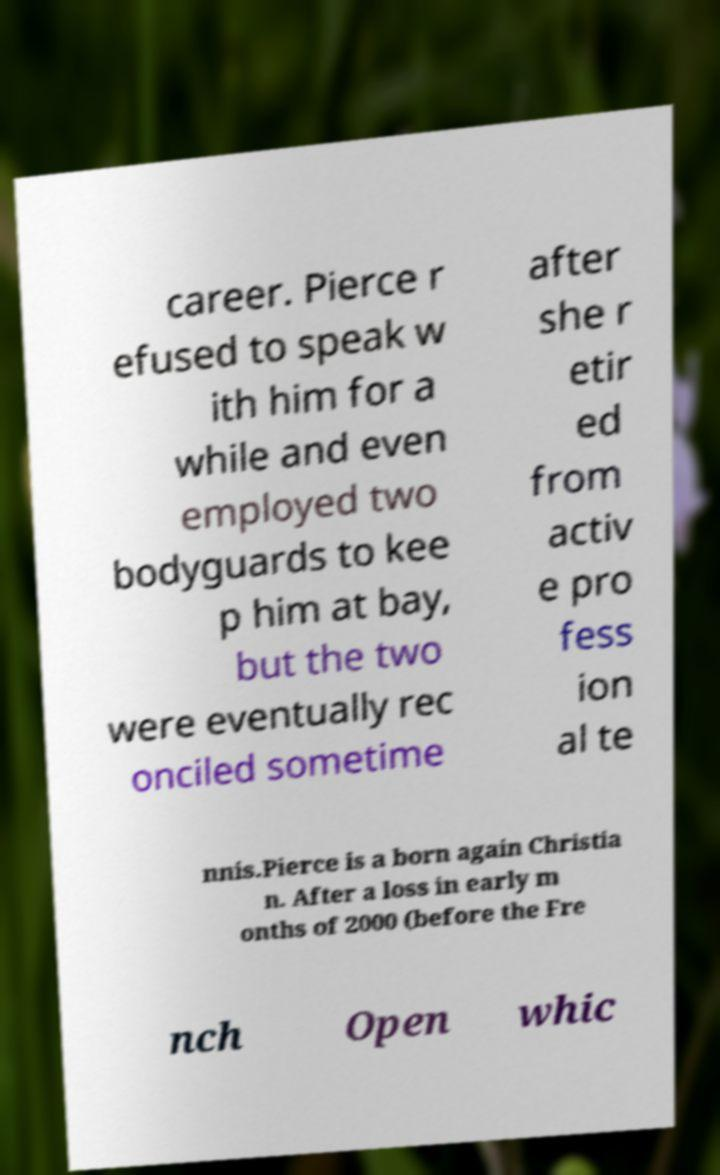There's text embedded in this image that I need extracted. Can you transcribe it verbatim? career. Pierce r efused to speak w ith him for a while and even employed two bodyguards to kee p him at bay, but the two were eventually rec onciled sometime after she r etir ed from activ e pro fess ion al te nnis.Pierce is a born again Christia n. After a loss in early m onths of 2000 (before the Fre nch Open whic 